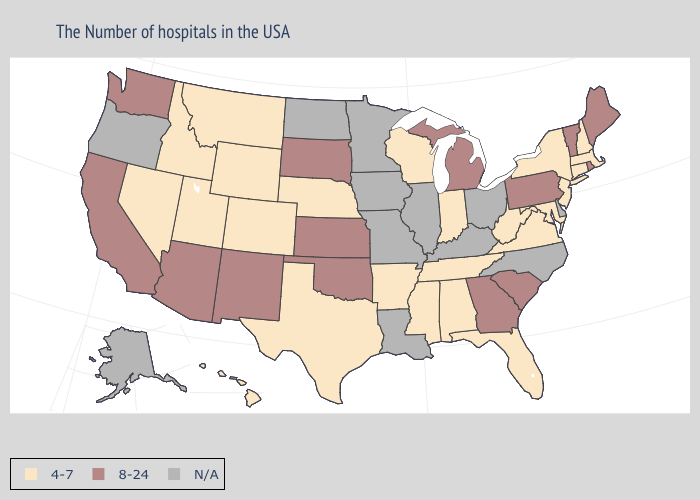How many symbols are there in the legend?
Short answer required. 3. Which states have the highest value in the USA?
Answer briefly. Maine, Rhode Island, Vermont, Pennsylvania, South Carolina, Georgia, Michigan, Kansas, Oklahoma, South Dakota, New Mexico, Arizona, California, Washington. Among the states that border Maine , which have the highest value?
Quick response, please. New Hampshire. Name the states that have a value in the range N/A?
Be succinct. Delaware, North Carolina, Ohio, Kentucky, Illinois, Louisiana, Missouri, Minnesota, Iowa, North Dakota, Oregon, Alaska. Name the states that have a value in the range N/A?
Be succinct. Delaware, North Carolina, Ohio, Kentucky, Illinois, Louisiana, Missouri, Minnesota, Iowa, North Dakota, Oregon, Alaska. Does Mississippi have the lowest value in the USA?
Give a very brief answer. Yes. What is the lowest value in the USA?
Write a very short answer. 4-7. Does Maryland have the highest value in the South?
Write a very short answer. No. What is the lowest value in states that border Montana?
Short answer required. 4-7. Name the states that have a value in the range 4-7?
Keep it brief. Massachusetts, New Hampshire, Connecticut, New York, New Jersey, Maryland, Virginia, West Virginia, Florida, Indiana, Alabama, Tennessee, Wisconsin, Mississippi, Arkansas, Nebraska, Texas, Wyoming, Colorado, Utah, Montana, Idaho, Nevada, Hawaii. Name the states that have a value in the range N/A?
Concise answer only. Delaware, North Carolina, Ohio, Kentucky, Illinois, Louisiana, Missouri, Minnesota, Iowa, North Dakota, Oregon, Alaska. What is the value of South Carolina?
Quick response, please. 8-24. Name the states that have a value in the range 4-7?
Keep it brief. Massachusetts, New Hampshire, Connecticut, New York, New Jersey, Maryland, Virginia, West Virginia, Florida, Indiana, Alabama, Tennessee, Wisconsin, Mississippi, Arkansas, Nebraska, Texas, Wyoming, Colorado, Utah, Montana, Idaho, Nevada, Hawaii. Which states hav the highest value in the South?
Short answer required. South Carolina, Georgia, Oklahoma. 